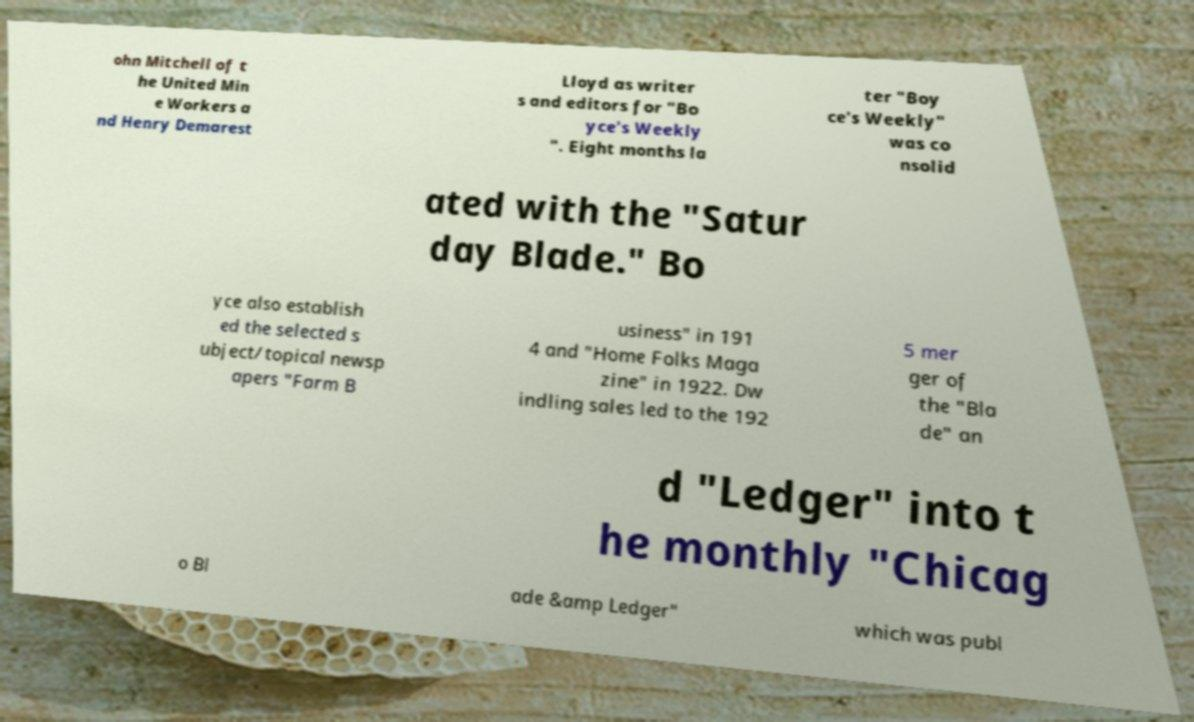Can you read and provide the text displayed in the image?This photo seems to have some interesting text. Can you extract and type it out for me? ohn Mitchell of t he United Min e Workers a nd Henry Demarest Lloyd as writer s and editors for "Bo yce's Weekly ". Eight months la ter "Boy ce's Weekly" was co nsolid ated with the "Satur day Blade." Bo yce also establish ed the selected s ubject/topical newsp apers "Farm B usiness" in 191 4 and "Home Folks Maga zine" in 1922. Dw indling sales led to the 192 5 mer ger of the "Bla de" an d "Ledger" into t he monthly "Chicag o Bl ade &amp Ledger" which was publ 